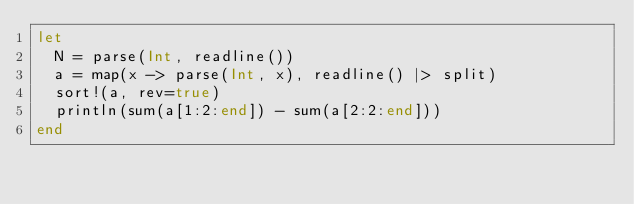<code> <loc_0><loc_0><loc_500><loc_500><_Julia_>let
  N = parse(Int, readline())
  a = map(x -> parse(Int, x), readline() |> split)
  sort!(a, rev=true)
  println(sum(a[1:2:end]) - sum(a[2:2:end]))
end</code> 